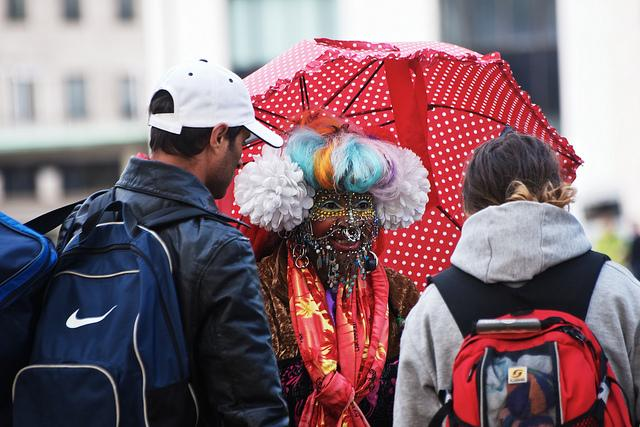What does the woman have all over her face? Please explain your reasoning. piercings. She has all different kind of piercings to decorate her face. 